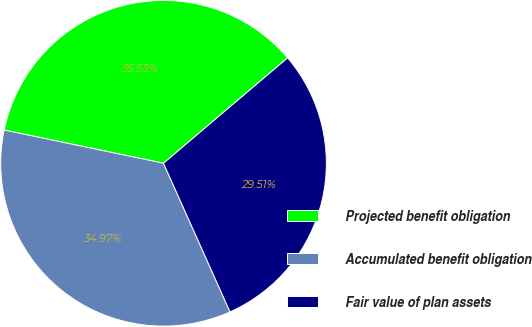<chart> <loc_0><loc_0><loc_500><loc_500><pie_chart><fcel>Projected benefit obligation<fcel>Accumulated benefit obligation<fcel>Fair value of plan assets<nl><fcel>35.53%<fcel>34.97%<fcel>29.51%<nl></chart> 